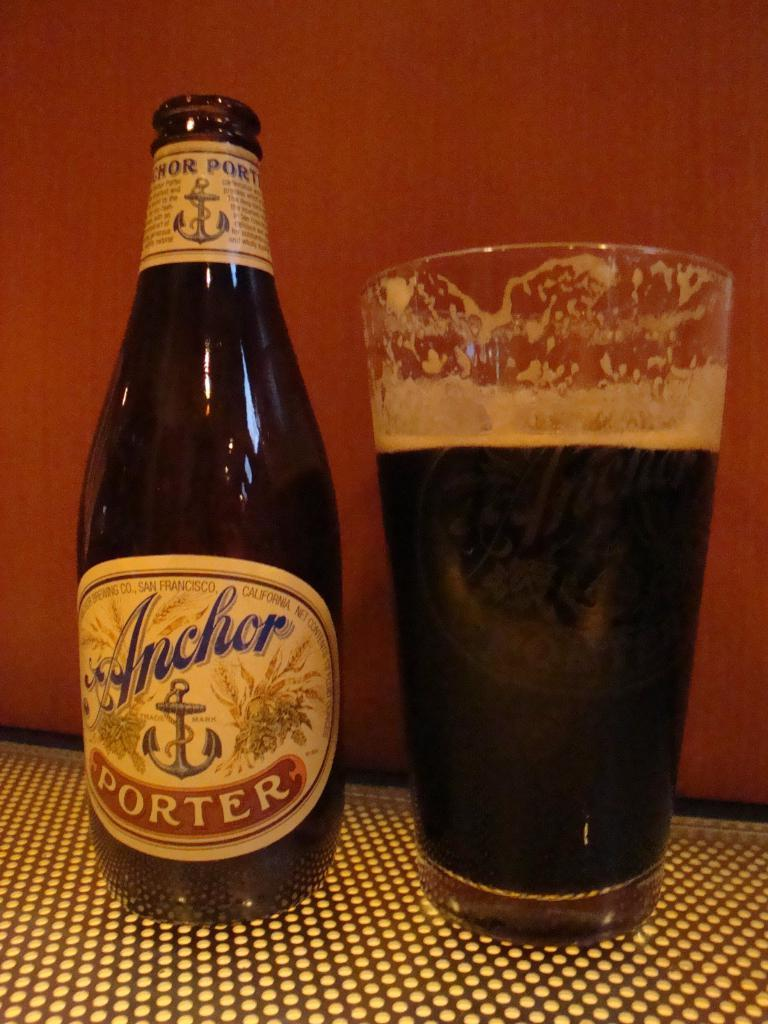Provide a one-sentence caption for the provided image. A bottle of Anchor Porter beer next to a glass of beer. 